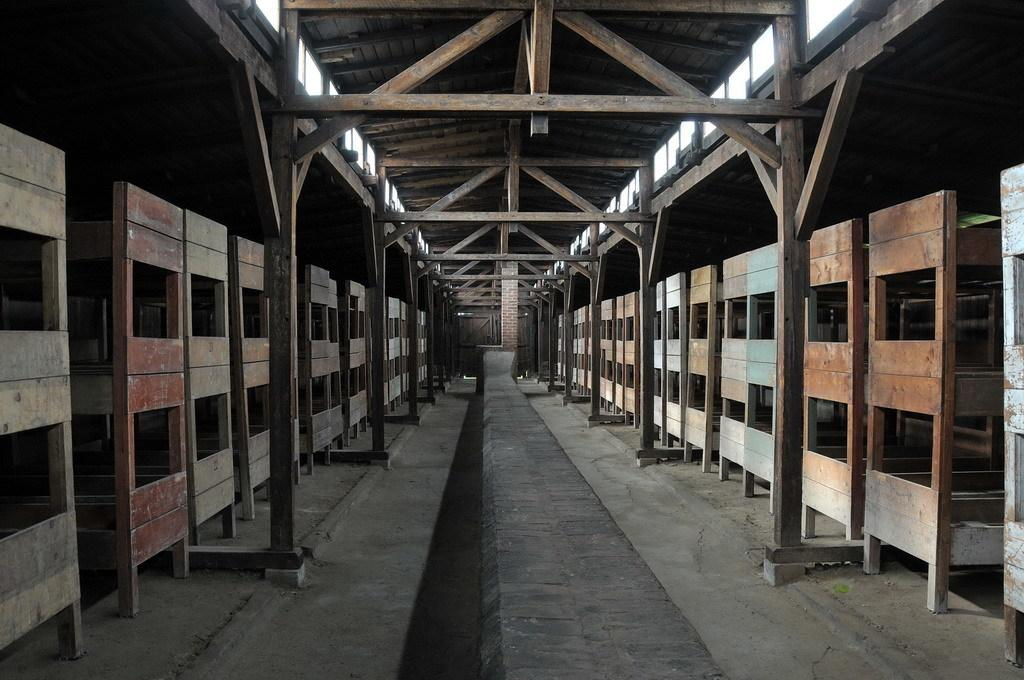What type of material is used for the objects in the image? There are many wooden objects in the image. What part of a structure can be seen in the image? There is a wooden roof in the image. What type of support is visible in the image? There are wooden poles in the image. What color is the crayon used to draw on the wooden objects in the image? There is no crayon present in the image, and therefore no such drawing can be observed. 